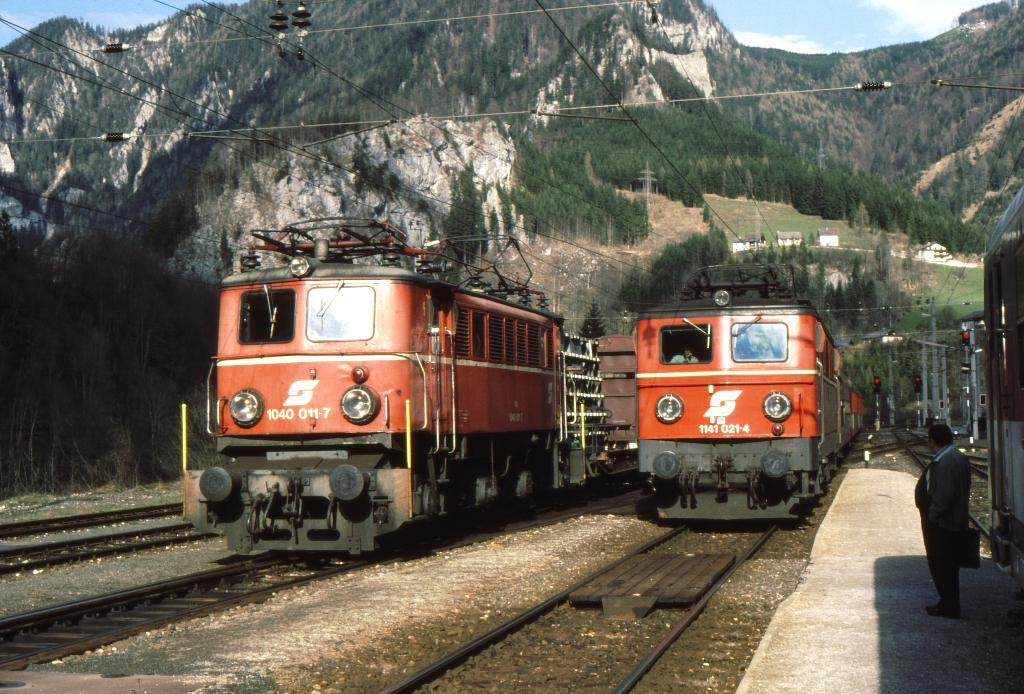<image>
Render a clear and concise summary of the photo. Train engines 1040 011-7 and 1141 021-4 are on parallel tracks below the mountains. 